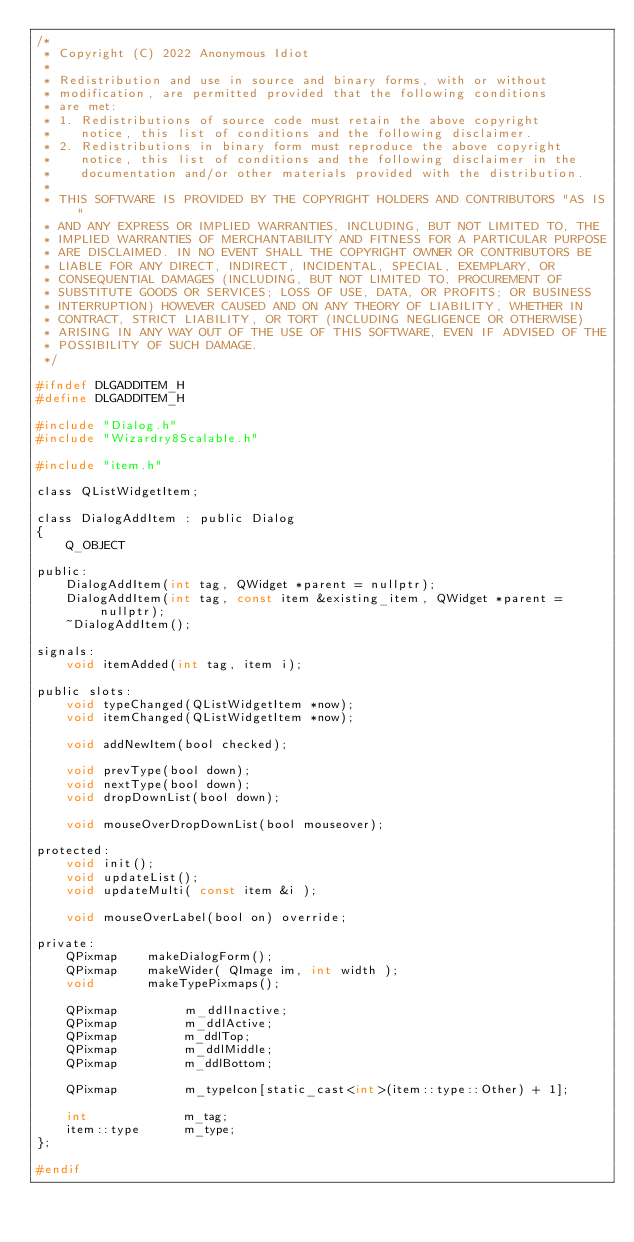<code> <loc_0><loc_0><loc_500><loc_500><_C_>/*
 * Copyright (C) 2022 Anonymous Idiot
 *
 * Redistribution and use in source and binary forms, with or without
 * modification, are permitted provided that the following conditions
 * are met:
 * 1. Redistributions of source code must retain the above copyright
 *    notice, this list of conditions and the following disclaimer.
 * 2. Redistributions in binary form must reproduce the above copyright
 *    notice, this list of conditions and the following disclaimer in the
 *    documentation and/or other materials provided with the distribution.
 *
 * THIS SOFTWARE IS PROVIDED BY THE COPYRIGHT HOLDERS AND CONTRIBUTORS "AS IS"
 * AND ANY EXPRESS OR IMPLIED WARRANTIES, INCLUDING, BUT NOT LIMITED TO, THE
 * IMPLIED WARRANTIES OF MERCHANTABILITY AND FITNESS FOR A PARTICULAR PURPOSE
 * ARE DISCLAIMED. IN NO EVENT SHALL THE COPYRIGHT OWNER OR CONTRIBUTORS BE
 * LIABLE FOR ANY DIRECT, INDIRECT, INCIDENTAL, SPECIAL, EXEMPLARY, OR
 * CONSEQUENTIAL DAMAGES (INCLUDING, BUT NOT LIMITED TO, PROCUREMENT OF
 * SUBSTITUTE GOODS OR SERVICES; LOSS OF USE, DATA, OR PROFITS; OR BUSINESS
 * INTERRUPTION) HOWEVER CAUSED AND ON ANY THEORY OF LIABILITY, WHETHER IN
 * CONTRACT, STRICT LIABILITY, OR TORT (INCLUDING NEGLIGENCE OR OTHERWISE)
 * ARISING IN ANY WAY OUT OF THE USE OF THIS SOFTWARE, EVEN IF ADVISED OF THE
 * POSSIBILITY OF SUCH DAMAGE.
 */

#ifndef DLGADDITEM_H
#define DLGADDITEM_H

#include "Dialog.h"
#include "Wizardry8Scalable.h"

#include "item.h"

class QListWidgetItem;

class DialogAddItem : public Dialog
{
    Q_OBJECT

public:
    DialogAddItem(int tag, QWidget *parent = nullptr);
    DialogAddItem(int tag, const item &existing_item, QWidget *parent = nullptr);
    ~DialogAddItem();

signals:
    void itemAdded(int tag, item i);

public slots:
    void typeChanged(QListWidgetItem *now);
    void itemChanged(QListWidgetItem *now);

    void addNewItem(bool checked);

    void prevType(bool down);
    void nextType(bool down);
    void dropDownList(bool down);

    void mouseOverDropDownList(bool mouseover);

protected:
    void init();
    void updateList();
    void updateMulti( const item &i );

    void mouseOverLabel(bool on) override;

private:
    QPixmap    makeDialogForm();
    QPixmap    makeWider( QImage im, int width );
    void       makeTypePixmaps();

    QPixmap         m_ddlInactive;
    QPixmap         m_ddlActive;
    QPixmap         m_ddlTop;
    QPixmap         m_ddlMiddle;
    QPixmap         m_ddlBottom;

    QPixmap         m_typeIcon[static_cast<int>(item::type::Other) + 1];

    int             m_tag;
    item::type      m_type;
};

#endif

</code> 